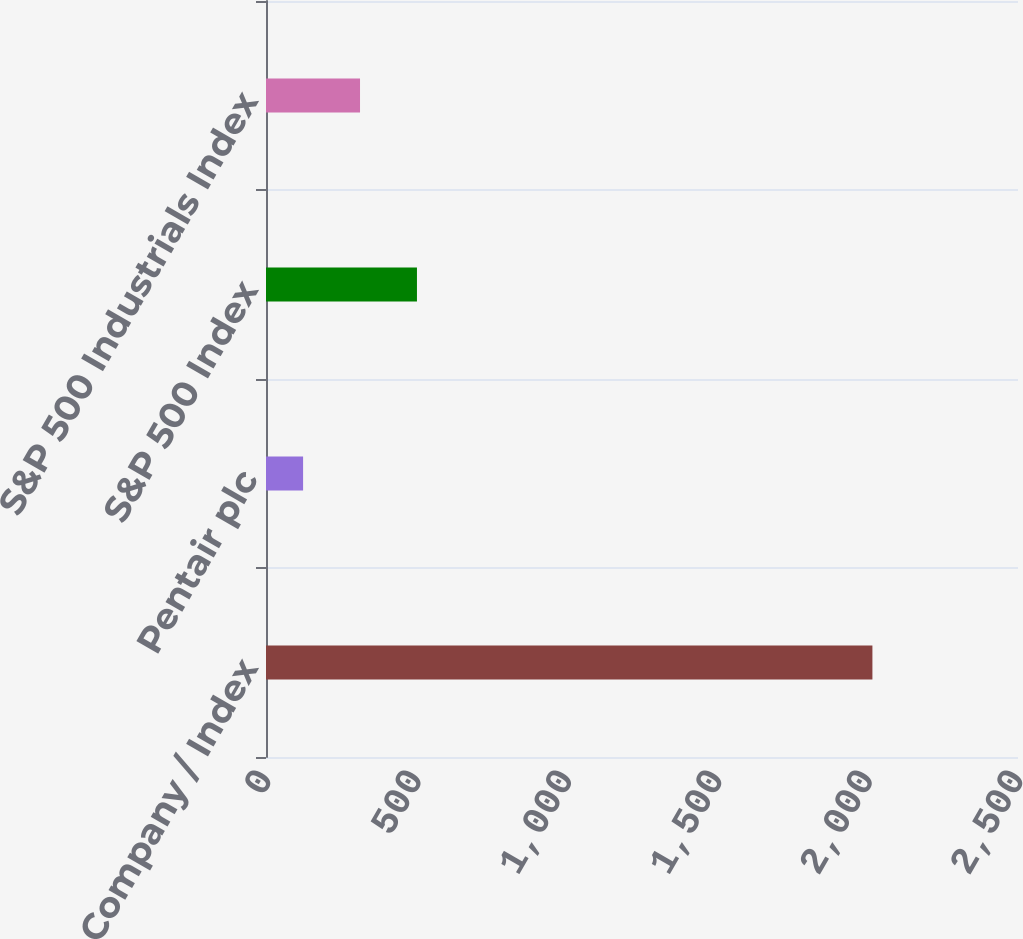<chart> <loc_0><loc_0><loc_500><loc_500><bar_chart><fcel>Company / Index<fcel>Pentair plc<fcel>S&P 500 Index<fcel>S&P 500 Industrials Index<nl><fcel>2016<fcel>123.32<fcel>501.86<fcel>312.59<nl></chart> 